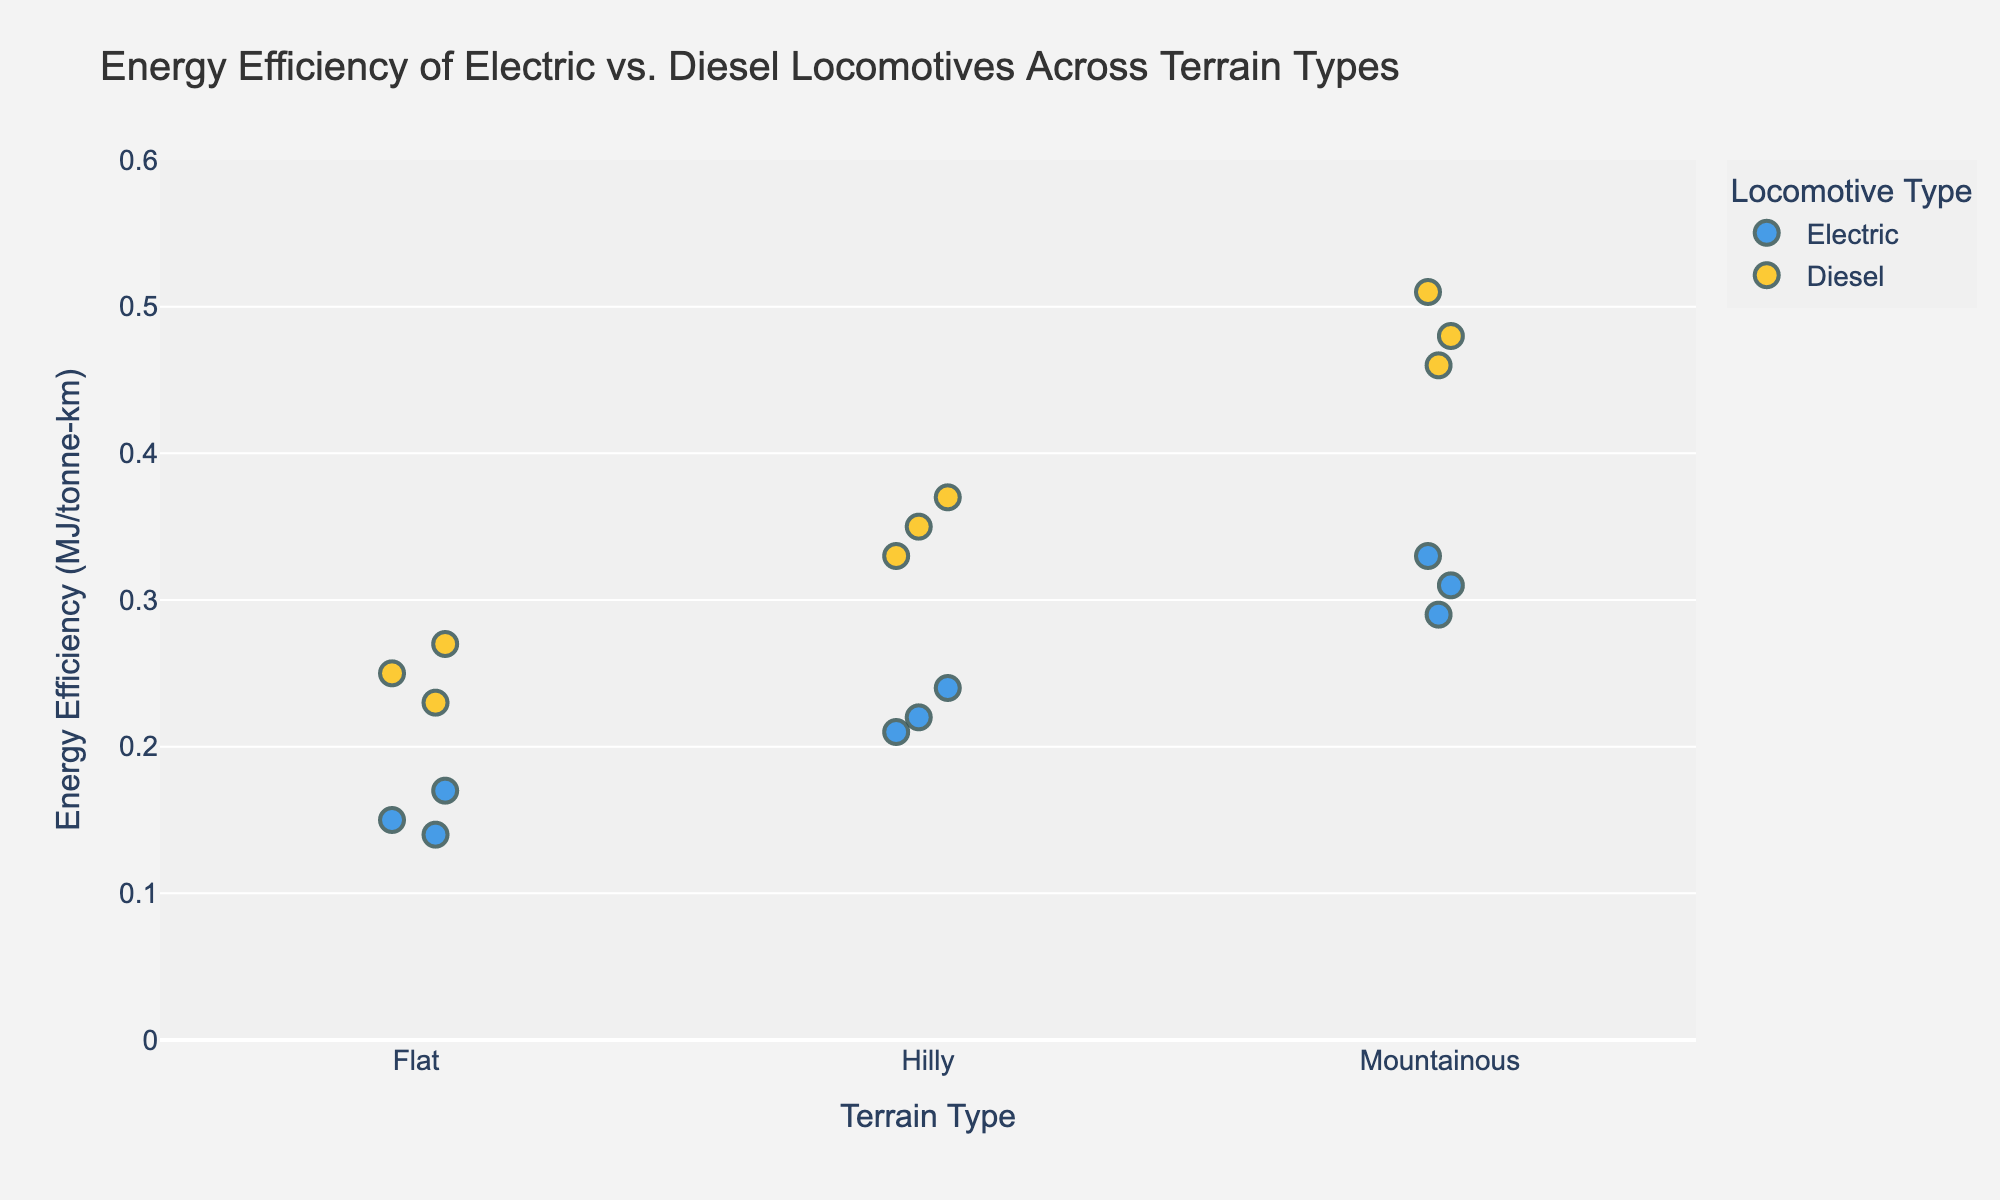Which locomotive type is represented by the blue dots? The color blue is used to represent electric locomotives in the legend provided.
Answer: Electric What is the maximum energy efficiency value for diesel locomotives on flat terrain? By observing the plot, the highest energy efficiency value among diesel locomotives on flat terrain is 0.27 MJ/tonne-km.
Answer: 0.27 MJ/tonne-km What is the average energy efficiency of electric locomotives on hilly terrain? The energy efficiency values for electric locomotives on hilly terrain are 0.22, 0.24, and 0.21 MJ/tonne-km. Their average is (0.22 + 0.24 + 0.21) / 3 = 0.2233 MJ/tonne-km.
Answer: 0.2233 MJ/tonne-km Which type of locomotive is more energy efficient on mountainous terrain? On mountainous terrain, electric locomotives have lower energy efficiency values (0.29, 0.31, and 0.33 MJ/tonne-km) compared to diesel locomotives (0.46, 0.48, and 0.51 MJ/tonne-km). Lower values indicate higher efficiency.
Answer: Electric How many total data points are represented in the plot? The total data points include 9 for electric locomotives and 9 for diesel locomotives, summing to 18.
Answer: 18 What is the difference in the highest energy efficiency values between electric and diesel locomotives on hilly terrain? The highest values on hilly terrain are 0.24 MJ/tonne-km for electric locomotives and 0.37 MJ/tonne-km for diesel locomotives. The difference is 0.37 - 0.24 = 0.13 MJ/tonne-km.
Answer: 0.13 MJ/tonne-km Which terrain type shows the largest variation in energy efficiency for electric locomotives? By visually comparing the spread of the dots for electric locomotives across terrain types, the mountainous terrain shows the largest variation with values ranging from 0.29 to 0.33 MJ/tonne-km.
Answer: Mountainous Is there any terrain type where diesel locomotives have lower energy efficiency than electric locomotives? Yes, on all terrain types (Flat, Hilly, Mountainous), diesel locomotives consistently have higher energy efficiency values compared to electric ones, indicating lower efficiency.
Answer: No 